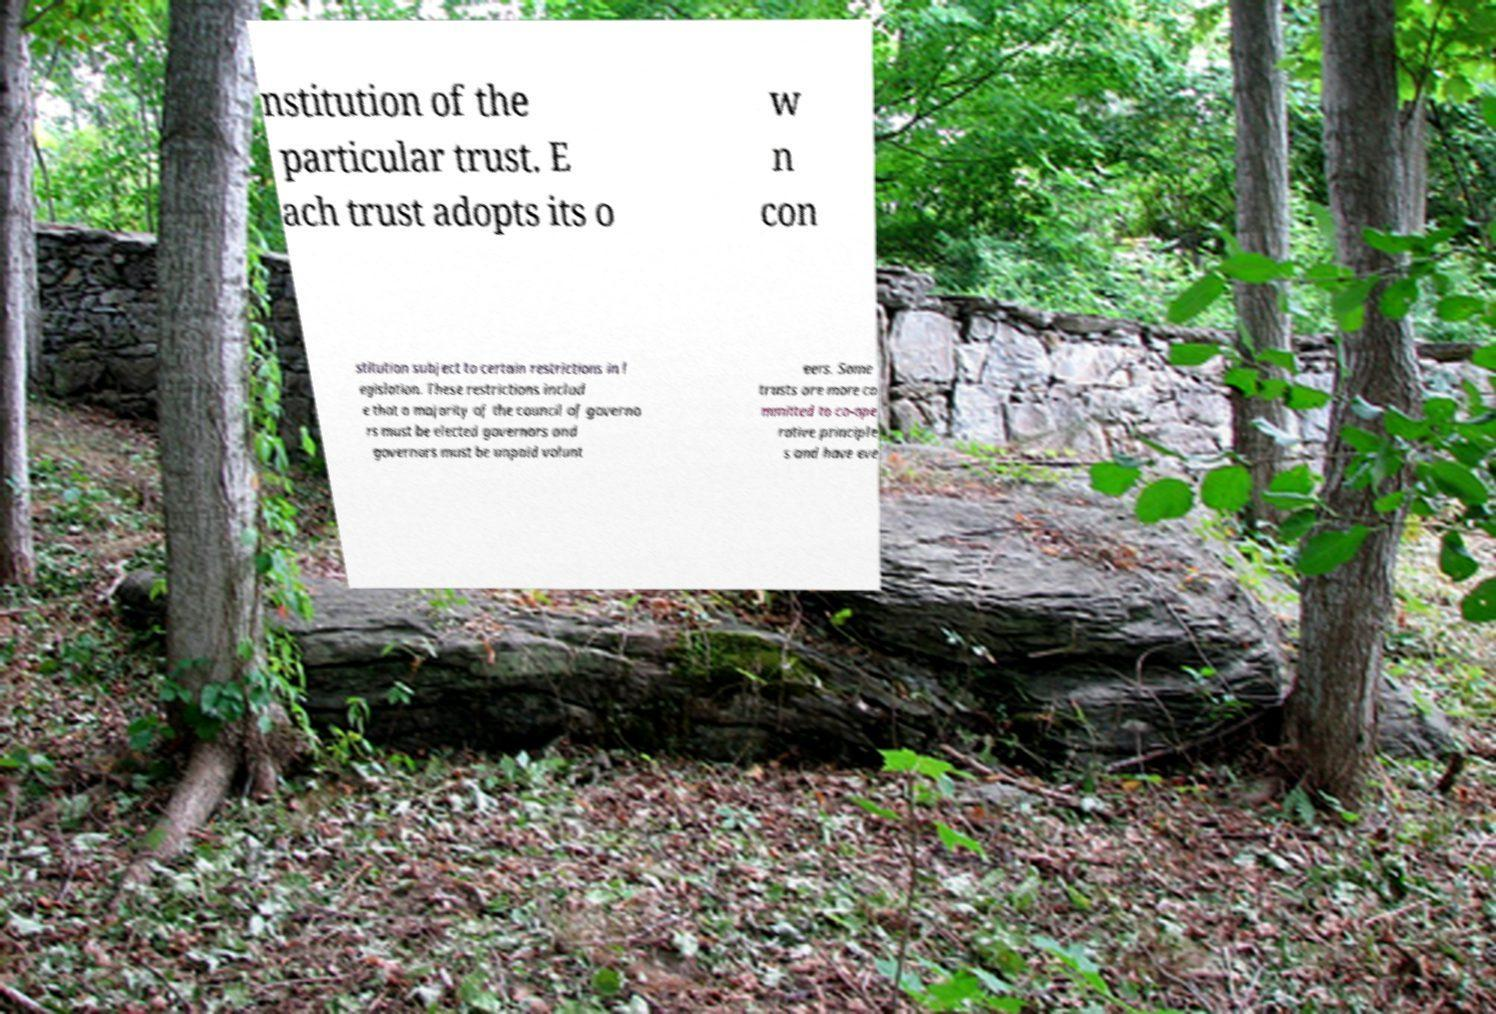For documentation purposes, I need the text within this image transcribed. Could you provide that? nstitution of the particular trust. E ach trust adopts its o w n con stitution subject to certain restrictions in l egislation. These restrictions includ e that a majority of the council of governo rs must be elected governors and governors must be unpaid volunt eers. Some trusts are more co mmitted to co-ope rative principle s and have eve 